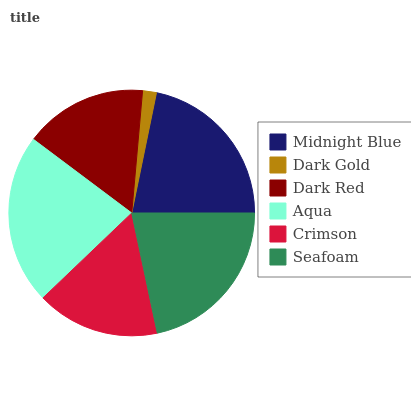Is Dark Gold the minimum?
Answer yes or no. Yes. Is Aqua the maximum?
Answer yes or no. Yes. Is Dark Red the minimum?
Answer yes or no. No. Is Dark Red the maximum?
Answer yes or no. No. Is Dark Red greater than Dark Gold?
Answer yes or no. Yes. Is Dark Gold less than Dark Red?
Answer yes or no. Yes. Is Dark Gold greater than Dark Red?
Answer yes or no. No. Is Dark Red less than Dark Gold?
Answer yes or no. No. Is Seafoam the high median?
Answer yes or no. Yes. Is Crimson the low median?
Answer yes or no. Yes. Is Dark Red the high median?
Answer yes or no. No. Is Seafoam the low median?
Answer yes or no. No. 